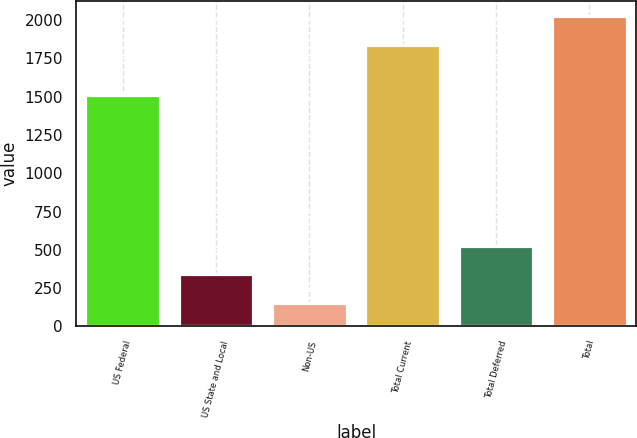Convert chart. <chart><loc_0><loc_0><loc_500><loc_500><bar_chart><fcel>US Federal<fcel>US State and Local<fcel>Non-US<fcel>Total Current<fcel>Total Deferred<fcel>Total<nl><fcel>1510<fcel>340.7<fcel>155<fcel>1838<fcel>526.4<fcel>2023.7<nl></chart> 